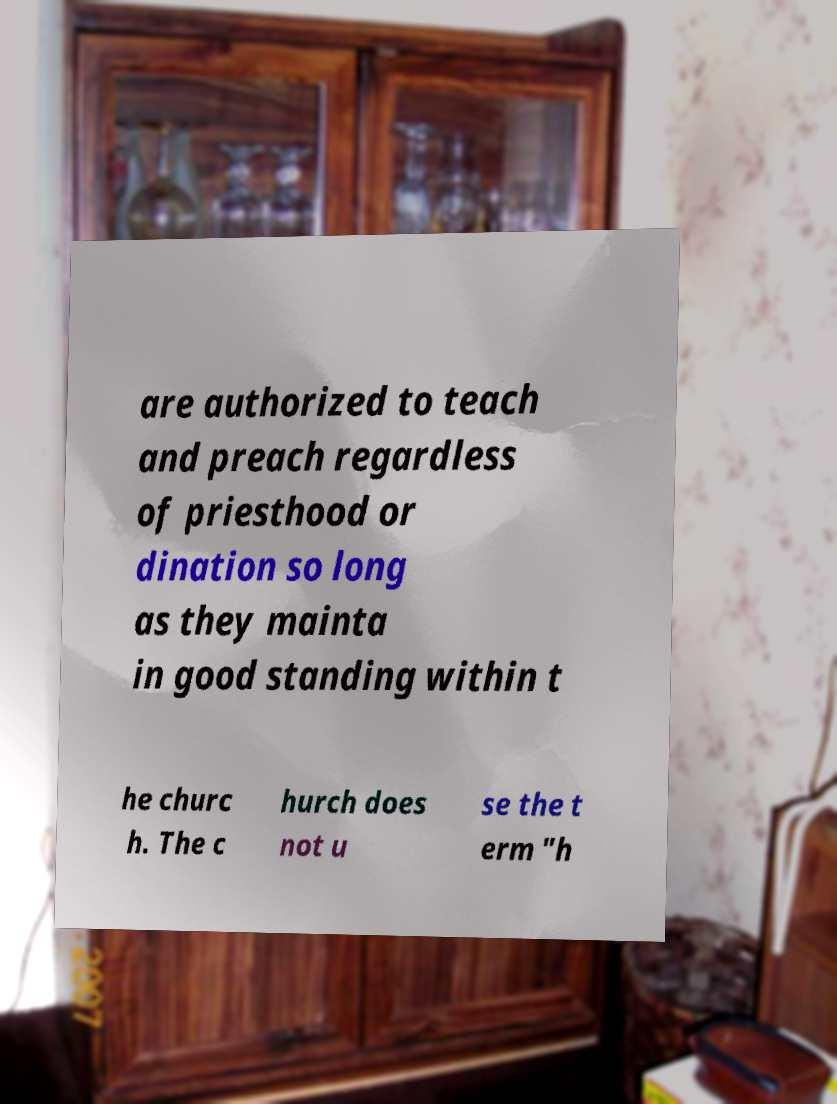Please read and relay the text visible in this image. What does it say? are authorized to teach and preach regardless of priesthood or dination so long as they mainta in good standing within t he churc h. The c hurch does not u se the t erm "h 